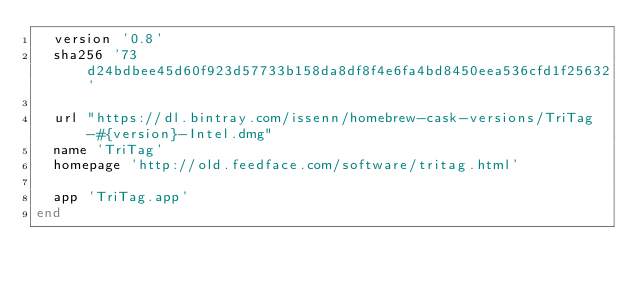<code> <loc_0><loc_0><loc_500><loc_500><_Ruby_>  version '0.8'
  sha256 '73d24bdbee45d60f923d57733b158da8df8f4e6fa4bd8450eea536cfd1f25632'

  url "https://dl.bintray.com/issenn/homebrew-cask-versions/TriTag-#{version}-Intel.dmg"
  name 'TriTag'
  homepage 'http://old.feedface.com/software/tritag.html'

  app 'TriTag.app'
end
</code> 